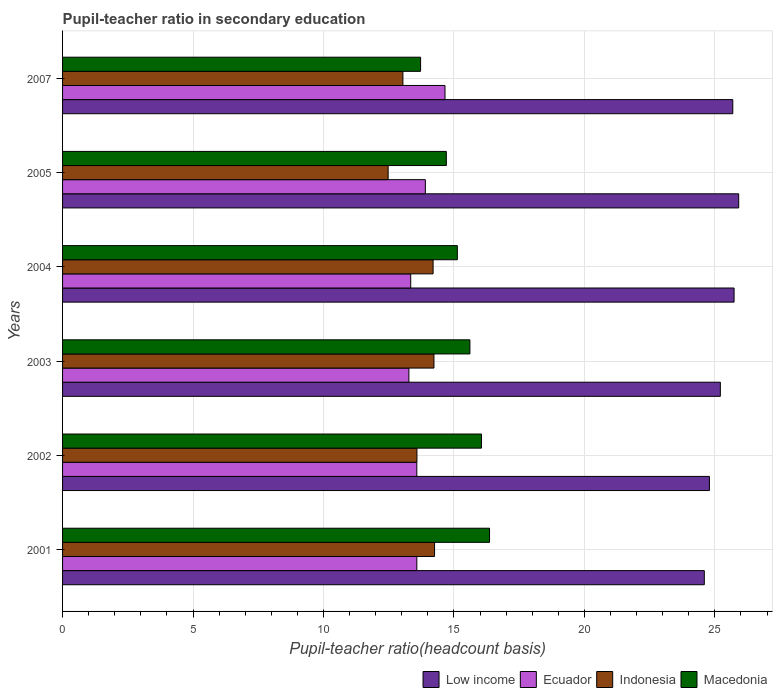How many different coloured bars are there?
Ensure brevity in your answer.  4. Are the number of bars per tick equal to the number of legend labels?
Keep it short and to the point. Yes. Are the number of bars on each tick of the Y-axis equal?
Offer a very short reply. Yes. How many bars are there on the 2nd tick from the bottom?
Offer a very short reply. 4. In how many cases, is the number of bars for a given year not equal to the number of legend labels?
Give a very brief answer. 0. What is the pupil-teacher ratio in secondary education in Low income in 2003?
Provide a succinct answer. 25.21. Across all years, what is the maximum pupil-teacher ratio in secondary education in Ecuador?
Provide a succinct answer. 14.66. Across all years, what is the minimum pupil-teacher ratio in secondary education in Indonesia?
Ensure brevity in your answer.  12.48. What is the total pupil-teacher ratio in secondary education in Macedonia in the graph?
Provide a short and direct response. 91.59. What is the difference between the pupil-teacher ratio in secondary education in Low income in 2001 and that in 2002?
Offer a terse response. -0.2. What is the difference between the pupil-teacher ratio in secondary education in Indonesia in 2003 and the pupil-teacher ratio in secondary education in Low income in 2002?
Your answer should be very brief. -10.56. What is the average pupil-teacher ratio in secondary education in Ecuador per year?
Give a very brief answer. 13.72. In the year 2001, what is the difference between the pupil-teacher ratio in secondary education in Indonesia and pupil-teacher ratio in secondary education in Macedonia?
Your answer should be very brief. -2.11. In how many years, is the pupil-teacher ratio in secondary education in Macedonia greater than 11 ?
Give a very brief answer. 6. What is the ratio of the pupil-teacher ratio in secondary education in Ecuador in 2001 to that in 2003?
Provide a succinct answer. 1.02. Is the pupil-teacher ratio in secondary education in Macedonia in 2003 less than that in 2004?
Ensure brevity in your answer.  No. What is the difference between the highest and the second highest pupil-teacher ratio in secondary education in Low income?
Your answer should be compact. 0.18. What is the difference between the highest and the lowest pupil-teacher ratio in secondary education in Low income?
Your response must be concise. 1.32. In how many years, is the pupil-teacher ratio in secondary education in Macedonia greater than the average pupil-teacher ratio in secondary education in Macedonia taken over all years?
Your answer should be compact. 3. Is the sum of the pupil-teacher ratio in secondary education in Macedonia in 2001 and 2002 greater than the maximum pupil-teacher ratio in secondary education in Low income across all years?
Your answer should be compact. Yes. Is it the case that in every year, the sum of the pupil-teacher ratio in secondary education in Low income and pupil-teacher ratio in secondary education in Indonesia is greater than the sum of pupil-teacher ratio in secondary education in Ecuador and pupil-teacher ratio in secondary education in Macedonia?
Your answer should be compact. Yes. What does the 3rd bar from the top in 2004 represents?
Make the answer very short. Ecuador. How many bars are there?
Offer a terse response. 24. Are all the bars in the graph horizontal?
Your answer should be compact. Yes. How many years are there in the graph?
Give a very brief answer. 6. Are the values on the major ticks of X-axis written in scientific E-notation?
Keep it short and to the point. No. Does the graph contain grids?
Your answer should be compact. Yes. Where does the legend appear in the graph?
Ensure brevity in your answer.  Bottom right. What is the title of the graph?
Keep it short and to the point. Pupil-teacher ratio in secondary education. Does "Malta" appear as one of the legend labels in the graph?
Offer a very short reply. No. What is the label or title of the X-axis?
Provide a short and direct response. Pupil-teacher ratio(headcount basis). What is the label or title of the Y-axis?
Offer a very short reply. Years. What is the Pupil-teacher ratio(headcount basis) in Low income in 2001?
Give a very brief answer. 24.6. What is the Pupil-teacher ratio(headcount basis) of Ecuador in 2001?
Keep it short and to the point. 13.58. What is the Pupil-teacher ratio(headcount basis) in Indonesia in 2001?
Provide a short and direct response. 14.26. What is the Pupil-teacher ratio(headcount basis) of Macedonia in 2001?
Your answer should be compact. 16.36. What is the Pupil-teacher ratio(headcount basis) of Low income in 2002?
Make the answer very short. 24.79. What is the Pupil-teacher ratio(headcount basis) of Ecuador in 2002?
Offer a terse response. 13.58. What is the Pupil-teacher ratio(headcount basis) of Indonesia in 2002?
Your response must be concise. 13.58. What is the Pupil-teacher ratio(headcount basis) in Macedonia in 2002?
Offer a very short reply. 16.06. What is the Pupil-teacher ratio(headcount basis) in Low income in 2003?
Offer a very short reply. 25.21. What is the Pupil-teacher ratio(headcount basis) in Ecuador in 2003?
Offer a terse response. 13.27. What is the Pupil-teacher ratio(headcount basis) of Indonesia in 2003?
Offer a very short reply. 14.23. What is the Pupil-teacher ratio(headcount basis) of Macedonia in 2003?
Offer a very short reply. 15.61. What is the Pupil-teacher ratio(headcount basis) in Low income in 2004?
Provide a short and direct response. 25.74. What is the Pupil-teacher ratio(headcount basis) of Ecuador in 2004?
Provide a short and direct response. 13.34. What is the Pupil-teacher ratio(headcount basis) of Indonesia in 2004?
Offer a very short reply. 14.2. What is the Pupil-teacher ratio(headcount basis) in Macedonia in 2004?
Your answer should be very brief. 15.13. What is the Pupil-teacher ratio(headcount basis) in Low income in 2005?
Offer a terse response. 25.91. What is the Pupil-teacher ratio(headcount basis) of Ecuador in 2005?
Keep it short and to the point. 13.9. What is the Pupil-teacher ratio(headcount basis) in Indonesia in 2005?
Your answer should be compact. 12.48. What is the Pupil-teacher ratio(headcount basis) of Macedonia in 2005?
Provide a succinct answer. 14.71. What is the Pupil-teacher ratio(headcount basis) in Low income in 2007?
Make the answer very short. 25.69. What is the Pupil-teacher ratio(headcount basis) in Ecuador in 2007?
Give a very brief answer. 14.66. What is the Pupil-teacher ratio(headcount basis) of Indonesia in 2007?
Ensure brevity in your answer.  13.04. What is the Pupil-teacher ratio(headcount basis) of Macedonia in 2007?
Offer a very short reply. 13.72. Across all years, what is the maximum Pupil-teacher ratio(headcount basis) of Low income?
Provide a succinct answer. 25.91. Across all years, what is the maximum Pupil-teacher ratio(headcount basis) of Ecuador?
Your response must be concise. 14.66. Across all years, what is the maximum Pupil-teacher ratio(headcount basis) in Indonesia?
Give a very brief answer. 14.26. Across all years, what is the maximum Pupil-teacher ratio(headcount basis) in Macedonia?
Your response must be concise. 16.36. Across all years, what is the minimum Pupil-teacher ratio(headcount basis) of Low income?
Provide a succinct answer. 24.6. Across all years, what is the minimum Pupil-teacher ratio(headcount basis) of Ecuador?
Offer a very short reply. 13.27. Across all years, what is the minimum Pupil-teacher ratio(headcount basis) of Indonesia?
Make the answer very short. 12.48. Across all years, what is the minimum Pupil-teacher ratio(headcount basis) of Macedonia?
Make the answer very short. 13.72. What is the total Pupil-teacher ratio(headcount basis) of Low income in the graph?
Give a very brief answer. 151.94. What is the total Pupil-teacher ratio(headcount basis) in Ecuador in the graph?
Offer a terse response. 82.33. What is the total Pupil-teacher ratio(headcount basis) of Indonesia in the graph?
Your response must be concise. 81.8. What is the total Pupil-teacher ratio(headcount basis) in Macedonia in the graph?
Keep it short and to the point. 91.59. What is the difference between the Pupil-teacher ratio(headcount basis) of Low income in 2001 and that in 2002?
Offer a very short reply. -0.2. What is the difference between the Pupil-teacher ratio(headcount basis) of Ecuador in 2001 and that in 2002?
Your answer should be compact. 0. What is the difference between the Pupil-teacher ratio(headcount basis) in Indonesia in 2001 and that in 2002?
Make the answer very short. 0.68. What is the difference between the Pupil-teacher ratio(headcount basis) in Macedonia in 2001 and that in 2002?
Your answer should be compact. 0.31. What is the difference between the Pupil-teacher ratio(headcount basis) in Low income in 2001 and that in 2003?
Give a very brief answer. -0.61. What is the difference between the Pupil-teacher ratio(headcount basis) in Ecuador in 2001 and that in 2003?
Provide a succinct answer. 0.3. What is the difference between the Pupil-teacher ratio(headcount basis) of Indonesia in 2001 and that in 2003?
Offer a very short reply. 0.02. What is the difference between the Pupil-teacher ratio(headcount basis) in Macedonia in 2001 and that in 2003?
Ensure brevity in your answer.  0.75. What is the difference between the Pupil-teacher ratio(headcount basis) in Low income in 2001 and that in 2004?
Your answer should be compact. -1.14. What is the difference between the Pupil-teacher ratio(headcount basis) in Ecuador in 2001 and that in 2004?
Your answer should be compact. 0.24. What is the difference between the Pupil-teacher ratio(headcount basis) in Indonesia in 2001 and that in 2004?
Provide a short and direct response. 0.06. What is the difference between the Pupil-teacher ratio(headcount basis) of Macedonia in 2001 and that in 2004?
Offer a very short reply. 1.23. What is the difference between the Pupil-teacher ratio(headcount basis) in Low income in 2001 and that in 2005?
Your response must be concise. -1.32. What is the difference between the Pupil-teacher ratio(headcount basis) of Ecuador in 2001 and that in 2005?
Provide a succinct answer. -0.33. What is the difference between the Pupil-teacher ratio(headcount basis) of Indonesia in 2001 and that in 2005?
Your answer should be compact. 1.78. What is the difference between the Pupil-teacher ratio(headcount basis) in Macedonia in 2001 and that in 2005?
Provide a short and direct response. 1.66. What is the difference between the Pupil-teacher ratio(headcount basis) of Low income in 2001 and that in 2007?
Offer a very short reply. -1.09. What is the difference between the Pupil-teacher ratio(headcount basis) of Ecuador in 2001 and that in 2007?
Ensure brevity in your answer.  -1.08. What is the difference between the Pupil-teacher ratio(headcount basis) in Indonesia in 2001 and that in 2007?
Offer a very short reply. 1.21. What is the difference between the Pupil-teacher ratio(headcount basis) of Macedonia in 2001 and that in 2007?
Provide a succinct answer. 2.64. What is the difference between the Pupil-teacher ratio(headcount basis) of Low income in 2002 and that in 2003?
Your answer should be very brief. -0.42. What is the difference between the Pupil-teacher ratio(headcount basis) of Ecuador in 2002 and that in 2003?
Offer a terse response. 0.3. What is the difference between the Pupil-teacher ratio(headcount basis) of Indonesia in 2002 and that in 2003?
Give a very brief answer. -0.65. What is the difference between the Pupil-teacher ratio(headcount basis) in Macedonia in 2002 and that in 2003?
Provide a short and direct response. 0.44. What is the difference between the Pupil-teacher ratio(headcount basis) in Low income in 2002 and that in 2004?
Your answer should be compact. -0.94. What is the difference between the Pupil-teacher ratio(headcount basis) of Ecuador in 2002 and that in 2004?
Keep it short and to the point. 0.23. What is the difference between the Pupil-teacher ratio(headcount basis) of Indonesia in 2002 and that in 2004?
Your answer should be compact. -0.62. What is the difference between the Pupil-teacher ratio(headcount basis) in Macedonia in 2002 and that in 2004?
Give a very brief answer. 0.92. What is the difference between the Pupil-teacher ratio(headcount basis) of Low income in 2002 and that in 2005?
Give a very brief answer. -1.12. What is the difference between the Pupil-teacher ratio(headcount basis) in Ecuador in 2002 and that in 2005?
Give a very brief answer. -0.33. What is the difference between the Pupil-teacher ratio(headcount basis) in Indonesia in 2002 and that in 2005?
Your response must be concise. 1.1. What is the difference between the Pupil-teacher ratio(headcount basis) of Macedonia in 2002 and that in 2005?
Keep it short and to the point. 1.35. What is the difference between the Pupil-teacher ratio(headcount basis) in Low income in 2002 and that in 2007?
Make the answer very short. -0.9. What is the difference between the Pupil-teacher ratio(headcount basis) in Ecuador in 2002 and that in 2007?
Offer a very short reply. -1.08. What is the difference between the Pupil-teacher ratio(headcount basis) of Indonesia in 2002 and that in 2007?
Your answer should be compact. 0.54. What is the difference between the Pupil-teacher ratio(headcount basis) of Macedonia in 2002 and that in 2007?
Ensure brevity in your answer.  2.33. What is the difference between the Pupil-teacher ratio(headcount basis) of Low income in 2003 and that in 2004?
Offer a very short reply. -0.53. What is the difference between the Pupil-teacher ratio(headcount basis) in Ecuador in 2003 and that in 2004?
Give a very brief answer. -0.07. What is the difference between the Pupil-teacher ratio(headcount basis) of Indonesia in 2003 and that in 2004?
Your answer should be very brief. 0.03. What is the difference between the Pupil-teacher ratio(headcount basis) in Macedonia in 2003 and that in 2004?
Provide a short and direct response. 0.48. What is the difference between the Pupil-teacher ratio(headcount basis) of Low income in 2003 and that in 2005?
Provide a short and direct response. -0.7. What is the difference between the Pupil-teacher ratio(headcount basis) in Ecuador in 2003 and that in 2005?
Ensure brevity in your answer.  -0.63. What is the difference between the Pupil-teacher ratio(headcount basis) of Indonesia in 2003 and that in 2005?
Offer a terse response. 1.76. What is the difference between the Pupil-teacher ratio(headcount basis) in Macedonia in 2003 and that in 2005?
Offer a very short reply. 0.9. What is the difference between the Pupil-teacher ratio(headcount basis) of Low income in 2003 and that in 2007?
Keep it short and to the point. -0.48. What is the difference between the Pupil-teacher ratio(headcount basis) of Ecuador in 2003 and that in 2007?
Your answer should be compact. -1.38. What is the difference between the Pupil-teacher ratio(headcount basis) of Indonesia in 2003 and that in 2007?
Your response must be concise. 1.19. What is the difference between the Pupil-teacher ratio(headcount basis) of Macedonia in 2003 and that in 2007?
Give a very brief answer. 1.89. What is the difference between the Pupil-teacher ratio(headcount basis) in Low income in 2004 and that in 2005?
Offer a very short reply. -0.18. What is the difference between the Pupil-teacher ratio(headcount basis) of Ecuador in 2004 and that in 2005?
Make the answer very short. -0.56. What is the difference between the Pupil-teacher ratio(headcount basis) of Indonesia in 2004 and that in 2005?
Ensure brevity in your answer.  1.72. What is the difference between the Pupil-teacher ratio(headcount basis) in Macedonia in 2004 and that in 2005?
Offer a terse response. 0.42. What is the difference between the Pupil-teacher ratio(headcount basis) in Low income in 2004 and that in 2007?
Offer a very short reply. 0.05. What is the difference between the Pupil-teacher ratio(headcount basis) of Ecuador in 2004 and that in 2007?
Offer a terse response. -1.31. What is the difference between the Pupil-teacher ratio(headcount basis) in Indonesia in 2004 and that in 2007?
Keep it short and to the point. 1.16. What is the difference between the Pupil-teacher ratio(headcount basis) of Macedonia in 2004 and that in 2007?
Keep it short and to the point. 1.41. What is the difference between the Pupil-teacher ratio(headcount basis) in Low income in 2005 and that in 2007?
Offer a very short reply. 0.23. What is the difference between the Pupil-teacher ratio(headcount basis) in Ecuador in 2005 and that in 2007?
Your response must be concise. -0.75. What is the difference between the Pupil-teacher ratio(headcount basis) of Indonesia in 2005 and that in 2007?
Provide a succinct answer. -0.57. What is the difference between the Pupil-teacher ratio(headcount basis) in Macedonia in 2005 and that in 2007?
Provide a short and direct response. 0.99. What is the difference between the Pupil-teacher ratio(headcount basis) in Low income in 2001 and the Pupil-teacher ratio(headcount basis) in Ecuador in 2002?
Offer a very short reply. 11.02. What is the difference between the Pupil-teacher ratio(headcount basis) in Low income in 2001 and the Pupil-teacher ratio(headcount basis) in Indonesia in 2002?
Offer a terse response. 11.01. What is the difference between the Pupil-teacher ratio(headcount basis) in Low income in 2001 and the Pupil-teacher ratio(headcount basis) in Macedonia in 2002?
Keep it short and to the point. 8.54. What is the difference between the Pupil-teacher ratio(headcount basis) of Ecuador in 2001 and the Pupil-teacher ratio(headcount basis) of Indonesia in 2002?
Give a very brief answer. -0. What is the difference between the Pupil-teacher ratio(headcount basis) in Ecuador in 2001 and the Pupil-teacher ratio(headcount basis) in Macedonia in 2002?
Make the answer very short. -2.48. What is the difference between the Pupil-teacher ratio(headcount basis) of Indonesia in 2001 and the Pupil-teacher ratio(headcount basis) of Macedonia in 2002?
Offer a very short reply. -1.8. What is the difference between the Pupil-teacher ratio(headcount basis) of Low income in 2001 and the Pupil-teacher ratio(headcount basis) of Ecuador in 2003?
Your answer should be very brief. 11.32. What is the difference between the Pupil-teacher ratio(headcount basis) in Low income in 2001 and the Pupil-teacher ratio(headcount basis) in Indonesia in 2003?
Ensure brevity in your answer.  10.36. What is the difference between the Pupil-teacher ratio(headcount basis) of Low income in 2001 and the Pupil-teacher ratio(headcount basis) of Macedonia in 2003?
Offer a very short reply. 8.98. What is the difference between the Pupil-teacher ratio(headcount basis) in Ecuador in 2001 and the Pupil-teacher ratio(headcount basis) in Indonesia in 2003?
Offer a very short reply. -0.66. What is the difference between the Pupil-teacher ratio(headcount basis) of Ecuador in 2001 and the Pupil-teacher ratio(headcount basis) of Macedonia in 2003?
Your response must be concise. -2.03. What is the difference between the Pupil-teacher ratio(headcount basis) of Indonesia in 2001 and the Pupil-teacher ratio(headcount basis) of Macedonia in 2003?
Keep it short and to the point. -1.36. What is the difference between the Pupil-teacher ratio(headcount basis) of Low income in 2001 and the Pupil-teacher ratio(headcount basis) of Ecuador in 2004?
Your answer should be very brief. 11.25. What is the difference between the Pupil-teacher ratio(headcount basis) of Low income in 2001 and the Pupil-teacher ratio(headcount basis) of Indonesia in 2004?
Your response must be concise. 10.39. What is the difference between the Pupil-teacher ratio(headcount basis) of Low income in 2001 and the Pupil-teacher ratio(headcount basis) of Macedonia in 2004?
Your response must be concise. 9.47. What is the difference between the Pupil-teacher ratio(headcount basis) of Ecuador in 2001 and the Pupil-teacher ratio(headcount basis) of Indonesia in 2004?
Offer a terse response. -0.62. What is the difference between the Pupil-teacher ratio(headcount basis) of Ecuador in 2001 and the Pupil-teacher ratio(headcount basis) of Macedonia in 2004?
Offer a very short reply. -1.55. What is the difference between the Pupil-teacher ratio(headcount basis) of Indonesia in 2001 and the Pupil-teacher ratio(headcount basis) of Macedonia in 2004?
Your answer should be compact. -0.87. What is the difference between the Pupil-teacher ratio(headcount basis) of Low income in 2001 and the Pupil-teacher ratio(headcount basis) of Ecuador in 2005?
Offer a very short reply. 10.69. What is the difference between the Pupil-teacher ratio(headcount basis) in Low income in 2001 and the Pupil-teacher ratio(headcount basis) in Indonesia in 2005?
Keep it short and to the point. 12.12. What is the difference between the Pupil-teacher ratio(headcount basis) of Low income in 2001 and the Pupil-teacher ratio(headcount basis) of Macedonia in 2005?
Provide a succinct answer. 9.89. What is the difference between the Pupil-teacher ratio(headcount basis) of Ecuador in 2001 and the Pupil-teacher ratio(headcount basis) of Indonesia in 2005?
Keep it short and to the point. 1.1. What is the difference between the Pupil-teacher ratio(headcount basis) of Ecuador in 2001 and the Pupil-teacher ratio(headcount basis) of Macedonia in 2005?
Ensure brevity in your answer.  -1.13. What is the difference between the Pupil-teacher ratio(headcount basis) in Indonesia in 2001 and the Pupil-teacher ratio(headcount basis) in Macedonia in 2005?
Provide a short and direct response. -0.45. What is the difference between the Pupil-teacher ratio(headcount basis) of Low income in 2001 and the Pupil-teacher ratio(headcount basis) of Ecuador in 2007?
Your answer should be compact. 9.94. What is the difference between the Pupil-teacher ratio(headcount basis) in Low income in 2001 and the Pupil-teacher ratio(headcount basis) in Indonesia in 2007?
Your response must be concise. 11.55. What is the difference between the Pupil-teacher ratio(headcount basis) in Low income in 2001 and the Pupil-teacher ratio(headcount basis) in Macedonia in 2007?
Your response must be concise. 10.87. What is the difference between the Pupil-teacher ratio(headcount basis) of Ecuador in 2001 and the Pupil-teacher ratio(headcount basis) of Indonesia in 2007?
Provide a short and direct response. 0.53. What is the difference between the Pupil-teacher ratio(headcount basis) of Ecuador in 2001 and the Pupil-teacher ratio(headcount basis) of Macedonia in 2007?
Make the answer very short. -0.14. What is the difference between the Pupil-teacher ratio(headcount basis) of Indonesia in 2001 and the Pupil-teacher ratio(headcount basis) of Macedonia in 2007?
Your response must be concise. 0.54. What is the difference between the Pupil-teacher ratio(headcount basis) in Low income in 2002 and the Pupil-teacher ratio(headcount basis) in Ecuador in 2003?
Your answer should be very brief. 11.52. What is the difference between the Pupil-teacher ratio(headcount basis) of Low income in 2002 and the Pupil-teacher ratio(headcount basis) of Indonesia in 2003?
Provide a short and direct response. 10.56. What is the difference between the Pupil-teacher ratio(headcount basis) in Low income in 2002 and the Pupil-teacher ratio(headcount basis) in Macedonia in 2003?
Give a very brief answer. 9.18. What is the difference between the Pupil-teacher ratio(headcount basis) of Ecuador in 2002 and the Pupil-teacher ratio(headcount basis) of Indonesia in 2003?
Offer a terse response. -0.66. What is the difference between the Pupil-teacher ratio(headcount basis) of Ecuador in 2002 and the Pupil-teacher ratio(headcount basis) of Macedonia in 2003?
Ensure brevity in your answer.  -2.03. What is the difference between the Pupil-teacher ratio(headcount basis) of Indonesia in 2002 and the Pupil-teacher ratio(headcount basis) of Macedonia in 2003?
Provide a succinct answer. -2.03. What is the difference between the Pupil-teacher ratio(headcount basis) in Low income in 2002 and the Pupil-teacher ratio(headcount basis) in Ecuador in 2004?
Offer a terse response. 11.45. What is the difference between the Pupil-teacher ratio(headcount basis) of Low income in 2002 and the Pupil-teacher ratio(headcount basis) of Indonesia in 2004?
Keep it short and to the point. 10.59. What is the difference between the Pupil-teacher ratio(headcount basis) in Low income in 2002 and the Pupil-teacher ratio(headcount basis) in Macedonia in 2004?
Give a very brief answer. 9.66. What is the difference between the Pupil-teacher ratio(headcount basis) of Ecuador in 2002 and the Pupil-teacher ratio(headcount basis) of Indonesia in 2004?
Provide a short and direct response. -0.62. What is the difference between the Pupil-teacher ratio(headcount basis) of Ecuador in 2002 and the Pupil-teacher ratio(headcount basis) of Macedonia in 2004?
Ensure brevity in your answer.  -1.55. What is the difference between the Pupil-teacher ratio(headcount basis) in Indonesia in 2002 and the Pupil-teacher ratio(headcount basis) in Macedonia in 2004?
Offer a very short reply. -1.55. What is the difference between the Pupil-teacher ratio(headcount basis) of Low income in 2002 and the Pupil-teacher ratio(headcount basis) of Ecuador in 2005?
Offer a very short reply. 10.89. What is the difference between the Pupil-teacher ratio(headcount basis) in Low income in 2002 and the Pupil-teacher ratio(headcount basis) in Indonesia in 2005?
Provide a short and direct response. 12.31. What is the difference between the Pupil-teacher ratio(headcount basis) in Low income in 2002 and the Pupil-teacher ratio(headcount basis) in Macedonia in 2005?
Provide a succinct answer. 10.08. What is the difference between the Pupil-teacher ratio(headcount basis) of Ecuador in 2002 and the Pupil-teacher ratio(headcount basis) of Indonesia in 2005?
Your response must be concise. 1.1. What is the difference between the Pupil-teacher ratio(headcount basis) of Ecuador in 2002 and the Pupil-teacher ratio(headcount basis) of Macedonia in 2005?
Your answer should be compact. -1.13. What is the difference between the Pupil-teacher ratio(headcount basis) of Indonesia in 2002 and the Pupil-teacher ratio(headcount basis) of Macedonia in 2005?
Ensure brevity in your answer.  -1.13. What is the difference between the Pupil-teacher ratio(headcount basis) of Low income in 2002 and the Pupil-teacher ratio(headcount basis) of Ecuador in 2007?
Offer a very short reply. 10.13. What is the difference between the Pupil-teacher ratio(headcount basis) of Low income in 2002 and the Pupil-teacher ratio(headcount basis) of Indonesia in 2007?
Keep it short and to the point. 11.75. What is the difference between the Pupil-teacher ratio(headcount basis) of Low income in 2002 and the Pupil-teacher ratio(headcount basis) of Macedonia in 2007?
Give a very brief answer. 11.07. What is the difference between the Pupil-teacher ratio(headcount basis) in Ecuador in 2002 and the Pupil-teacher ratio(headcount basis) in Indonesia in 2007?
Keep it short and to the point. 0.53. What is the difference between the Pupil-teacher ratio(headcount basis) of Ecuador in 2002 and the Pupil-teacher ratio(headcount basis) of Macedonia in 2007?
Your response must be concise. -0.14. What is the difference between the Pupil-teacher ratio(headcount basis) of Indonesia in 2002 and the Pupil-teacher ratio(headcount basis) of Macedonia in 2007?
Give a very brief answer. -0.14. What is the difference between the Pupil-teacher ratio(headcount basis) of Low income in 2003 and the Pupil-teacher ratio(headcount basis) of Ecuador in 2004?
Make the answer very short. 11.87. What is the difference between the Pupil-teacher ratio(headcount basis) in Low income in 2003 and the Pupil-teacher ratio(headcount basis) in Indonesia in 2004?
Provide a short and direct response. 11.01. What is the difference between the Pupil-teacher ratio(headcount basis) of Low income in 2003 and the Pupil-teacher ratio(headcount basis) of Macedonia in 2004?
Offer a very short reply. 10.08. What is the difference between the Pupil-teacher ratio(headcount basis) in Ecuador in 2003 and the Pupil-teacher ratio(headcount basis) in Indonesia in 2004?
Provide a short and direct response. -0.93. What is the difference between the Pupil-teacher ratio(headcount basis) of Ecuador in 2003 and the Pupil-teacher ratio(headcount basis) of Macedonia in 2004?
Provide a short and direct response. -1.86. What is the difference between the Pupil-teacher ratio(headcount basis) in Indonesia in 2003 and the Pupil-teacher ratio(headcount basis) in Macedonia in 2004?
Give a very brief answer. -0.9. What is the difference between the Pupil-teacher ratio(headcount basis) of Low income in 2003 and the Pupil-teacher ratio(headcount basis) of Ecuador in 2005?
Your answer should be compact. 11.31. What is the difference between the Pupil-teacher ratio(headcount basis) of Low income in 2003 and the Pupil-teacher ratio(headcount basis) of Indonesia in 2005?
Provide a short and direct response. 12.73. What is the difference between the Pupil-teacher ratio(headcount basis) in Low income in 2003 and the Pupil-teacher ratio(headcount basis) in Macedonia in 2005?
Your response must be concise. 10.5. What is the difference between the Pupil-teacher ratio(headcount basis) of Ecuador in 2003 and the Pupil-teacher ratio(headcount basis) of Indonesia in 2005?
Ensure brevity in your answer.  0.8. What is the difference between the Pupil-teacher ratio(headcount basis) of Ecuador in 2003 and the Pupil-teacher ratio(headcount basis) of Macedonia in 2005?
Your answer should be compact. -1.43. What is the difference between the Pupil-teacher ratio(headcount basis) in Indonesia in 2003 and the Pupil-teacher ratio(headcount basis) in Macedonia in 2005?
Your answer should be compact. -0.47. What is the difference between the Pupil-teacher ratio(headcount basis) of Low income in 2003 and the Pupil-teacher ratio(headcount basis) of Ecuador in 2007?
Your response must be concise. 10.55. What is the difference between the Pupil-teacher ratio(headcount basis) of Low income in 2003 and the Pupil-teacher ratio(headcount basis) of Indonesia in 2007?
Your answer should be compact. 12.17. What is the difference between the Pupil-teacher ratio(headcount basis) of Low income in 2003 and the Pupil-teacher ratio(headcount basis) of Macedonia in 2007?
Provide a short and direct response. 11.49. What is the difference between the Pupil-teacher ratio(headcount basis) of Ecuador in 2003 and the Pupil-teacher ratio(headcount basis) of Indonesia in 2007?
Your response must be concise. 0.23. What is the difference between the Pupil-teacher ratio(headcount basis) of Ecuador in 2003 and the Pupil-teacher ratio(headcount basis) of Macedonia in 2007?
Provide a succinct answer. -0.45. What is the difference between the Pupil-teacher ratio(headcount basis) in Indonesia in 2003 and the Pupil-teacher ratio(headcount basis) in Macedonia in 2007?
Ensure brevity in your answer.  0.51. What is the difference between the Pupil-teacher ratio(headcount basis) in Low income in 2004 and the Pupil-teacher ratio(headcount basis) in Ecuador in 2005?
Offer a terse response. 11.83. What is the difference between the Pupil-teacher ratio(headcount basis) in Low income in 2004 and the Pupil-teacher ratio(headcount basis) in Indonesia in 2005?
Your answer should be very brief. 13.26. What is the difference between the Pupil-teacher ratio(headcount basis) in Low income in 2004 and the Pupil-teacher ratio(headcount basis) in Macedonia in 2005?
Make the answer very short. 11.03. What is the difference between the Pupil-teacher ratio(headcount basis) of Ecuador in 2004 and the Pupil-teacher ratio(headcount basis) of Indonesia in 2005?
Your answer should be compact. 0.86. What is the difference between the Pupil-teacher ratio(headcount basis) of Ecuador in 2004 and the Pupil-teacher ratio(headcount basis) of Macedonia in 2005?
Your answer should be very brief. -1.37. What is the difference between the Pupil-teacher ratio(headcount basis) of Indonesia in 2004 and the Pupil-teacher ratio(headcount basis) of Macedonia in 2005?
Offer a terse response. -0.51. What is the difference between the Pupil-teacher ratio(headcount basis) of Low income in 2004 and the Pupil-teacher ratio(headcount basis) of Ecuador in 2007?
Provide a short and direct response. 11.08. What is the difference between the Pupil-teacher ratio(headcount basis) in Low income in 2004 and the Pupil-teacher ratio(headcount basis) in Indonesia in 2007?
Offer a very short reply. 12.69. What is the difference between the Pupil-teacher ratio(headcount basis) of Low income in 2004 and the Pupil-teacher ratio(headcount basis) of Macedonia in 2007?
Keep it short and to the point. 12.01. What is the difference between the Pupil-teacher ratio(headcount basis) in Ecuador in 2004 and the Pupil-teacher ratio(headcount basis) in Indonesia in 2007?
Provide a short and direct response. 0.3. What is the difference between the Pupil-teacher ratio(headcount basis) in Ecuador in 2004 and the Pupil-teacher ratio(headcount basis) in Macedonia in 2007?
Give a very brief answer. -0.38. What is the difference between the Pupil-teacher ratio(headcount basis) of Indonesia in 2004 and the Pupil-teacher ratio(headcount basis) of Macedonia in 2007?
Ensure brevity in your answer.  0.48. What is the difference between the Pupil-teacher ratio(headcount basis) of Low income in 2005 and the Pupil-teacher ratio(headcount basis) of Ecuador in 2007?
Provide a succinct answer. 11.26. What is the difference between the Pupil-teacher ratio(headcount basis) of Low income in 2005 and the Pupil-teacher ratio(headcount basis) of Indonesia in 2007?
Ensure brevity in your answer.  12.87. What is the difference between the Pupil-teacher ratio(headcount basis) of Low income in 2005 and the Pupil-teacher ratio(headcount basis) of Macedonia in 2007?
Offer a very short reply. 12.19. What is the difference between the Pupil-teacher ratio(headcount basis) in Ecuador in 2005 and the Pupil-teacher ratio(headcount basis) in Indonesia in 2007?
Offer a terse response. 0.86. What is the difference between the Pupil-teacher ratio(headcount basis) in Ecuador in 2005 and the Pupil-teacher ratio(headcount basis) in Macedonia in 2007?
Provide a succinct answer. 0.18. What is the difference between the Pupil-teacher ratio(headcount basis) of Indonesia in 2005 and the Pupil-teacher ratio(headcount basis) of Macedonia in 2007?
Provide a short and direct response. -1.24. What is the average Pupil-teacher ratio(headcount basis) of Low income per year?
Offer a very short reply. 25.32. What is the average Pupil-teacher ratio(headcount basis) in Ecuador per year?
Offer a very short reply. 13.72. What is the average Pupil-teacher ratio(headcount basis) of Indonesia per year?
Offer a very short reply. 13.63. What is the average Pupil-teacher ratio(headcount basis) in Macedonia per year?
Keep it short and to the point. 15.27. In the year 2001, what is the difference between the Pupil-teacher ratio(headcount basis) in Low income and Pupil-teacher ratio(headcount basis) in Ecuador?
Your answer should be very brief. 11.02. In the year 2001, what is the difference between the Pupil-teacher ratio(headcount basis) in Low income and Pupil-teacher ratio(headcount basis) in Indonesia?
Make the answer very short. 10.34. In the year 2001, what is the difference between the Pupil-teacher ratio(headcount basis) in Low income and Pupil-teacher ratio(headcount basis) in Macedonia?
Make the answer very short. 8.23. In the year 2001, what is the difference between the Pupil-teacher ratio(headcount basis) of Ecuador and Pupil-teacher ratio(headcount basis) of Indonesia?
Provide a short and direct response. -0.68. In the year 2001, what is the difference between the Pupil-teacher ratio(headcount basis) in Ecuador and Pupil-teacher ratio(headcount basis) in Macedonia?
Ensure brevity in your answer.  -2.79. In the year 2001, what is the difference between the Pupil-teacher ratio(headcount basis) of Indonesia and Pupil-teacher ratio(headcount basis) of Macedonia?
Give a very brief answer. -2.11. In the year 2002, what is the difference between the Pupil-teacher ratio(headcount basis) in Low income and Pupil-teacher ratio(headcount basis) in Ecuador?
Your answer should be compact. 11.21. In the year 2002, what is the difference between the Pupil-teacher ratio(headcount basis) of Low income and Pupil-teacher ratio(headcount basis) of Indonesia?
Your answer should be compact. 11.21. In the year 2002, what is the difference between the Pupil-teacher ratio(headcount basis) in Low income and Pupil-teacher ratio(headcount basis) in Macedonia?
Provide a succinct answer. 8.74. In the year 2002, what is the difference between the Pupil-teacher ratio(headcount basis) of Ecuador and Pupil-teacher ratio(headcount basis) of Indonesia?
Provide a succinct answer. -0. In the year 2002, what is the difference between the Pupil-teacher ratio(headcount basis) in Ecuador and Pupil-teacher ratio(headcount basis) in Macedonia?
Keep it short and to the point. -2.48. In the year 2002, what is the difference between the Pupil-teacher ratio(headcount basis) of Indonesia and Pupil-teacher ratio(headcount basis) of Macedonia?
Provide a succinct answer. -2.47. In the year 2003, what is the difference between the Pupil-teacher ratio(headcount basis) in Low income and Pupil-teacher ratio(headcount basis) in Ecuador?
Offer a terse response. 11.94. In the year 2003, what is the difference between the Pupil-teacher ratio(headcount basis) in Low income and Pupil-teacher ratio(headcount basis) in Indonesia?
Your answer should be very brief. 10.98. In the year 2003, what is the difference between the Pupil-teacher ratio(headcount basis) in Low income and Pupil-teacher ratio(headcount basis) in Macedonia?
Provide a short and direct response. 9.6. In the year 2003, what is the difference between the Pupil-teacher ratio(headcount basis) in Ecuador and Pupil-teacher ratio(headcount basis) in Indonesia?
Keep it short and to the point. -0.96. In the year 2003, what is the difference between the Pupil-teacher ratio(headcount basis) of Ecuador and Pupil-teacher ratio(headcount basis) of Macedonia?
Offer a terse response. -2.34. In the year 2003, what is the difference between the Pupil-teacher ratio(headcount basis) in Indonesia and Pupil-teacher ratio(headcount basis) in Macedonia?
Make the answer very short. -1.38. In the year 2004, what is the difference between the Pupil-teacher ratio(headcount basis) of Low income and Pupil-teacher ratio(headcount basis) of Ecuador?
Provide a succinct answer. 12.39. In the year 2004, what is the difference between the Pupil-teacher ratio(headcount basis) in Low income and Pupil-teacher ratio(headcount basis) in Indonesia?
Your answer should be very brief. 11.54. In the year 2004, what is the difference between the Pupil-teacher ratio(headcount basis) in Low income and Pupil-teacher ratio(headcount basis) in Macedonia?
Your answer should be very brief. 10.61. In the year 2004, what is the difference between the Pupil-teacher ratio(headcount basis) in Ecuador and Pupil-teacher ratio(headcount basis) in Indonesia?
Provide a succinct answer. -0.86. In the year 2004, what is the difference between the Pupil-teacher ratio(headcount basis) of Ecuador and Pupil-teacher ratio(headcount basis) of Macedonia?
Keep it short and to the point. -1.79. In the year 2004, what is the difference between the Pupil-teacher ratio(headcount basis) in Indonesia and Pupil-teacher ratio(headcount basis) in Macedonia?
Your response must be concise. -0.93. In the year 2005, what is the difference between the Pupil-teacher ratio(headcount basis) of Low income and Pupil-teacher ratio(headcount basis) of Ecuador?
Make the answer very short. 12.01. In the year 2005, what is the difference between the Pupil-teacher ratio(headcount basis) in Low income and Pupil-teacher ratio(headcount basis) in Indonesia?
Offer a very short reply. 13.44. In the year 2005, what is the difference between the Pupil-teacher ratio(headcount basis) of Low income and Pupil-teacher ratio(headcount basis) of Macedonia?
Provide a short and direct response. 11.21. In the year 2005, what is the difference between the Pupil-teacher ratio(headcount basis) of Ecuador and Pupil-teacher ratio(headcount basis) of Indonesia?
Offer a terse response. 1.43. In the year 2005, what is the difference between the Pupil-teacher ratio(headcount basis) of Ecuador and Pupil-teacher ratio(headcount basis) of Macedonia?
Offer a very short reply. -0.8. In the year 2005, what is the difference between the Pupil-teacher ratio(headcount basis) of Indonesia and Pupil-teacher ratio(headcount basis) of Macedonia?
Ensure brevity in your answer.  -2.23. In the year 2007, what is the difference between the Pupil-teacher ratio(headcount basis) in Low income and Pupil-teacher ratio(headcount basis) in Ecuador?
Offer a terse response. 11.03. In the year 2007, what is the difference between the Pupil-teacher ratio(headcount basis) in Low income and Pupil-teacher ratio(headcount basis) in Indonesia?
Give a very brief answer. 12.64. In the year 2007, what is the difference between the Pupil-teacher ratio(headcount basis) in Low income and Pupil-teacher ratio(headcount basis) in Macedonia?
Make the answer very short. 11.97. In the year 2007, what is the difference between the Pupil-teacher ratio(headcount basis) in Ecuador and Pupil-teacher ratio(headcount basis) in Indonesia?
Ensure brevity in your answer.  1.61. In the year 2007, what is the difference between the Pupil-teacher ratio(headcount basis) of Ecuador and Pupil-teacher ratio(headcount basis) of Macedonia?
Offer a terse response. 0.94. In the year 2007, what is the difference between the Pupil-teacher ratio(headcount basis) of Indonesia and Pupil-teacher ratio(headcount basis) of Macedonia?
Your answer should be very brief. -0.68. What is the ratio of the Pupil-teacher ratio(headcount basis) of Low income in 2001 to that in 2002?
Provide a short and direct response. 0.99. What is the ratio of the Pupil-teacher ratio(headcount basis) of Indonesia in 2001 to that in 2002?
Make the answer very short. 1.05. What is the ratio of the Pupil-teacher ratio(headcount basis) in Macedonia in 2001 to that in 2002?
Offer a very short reply. 1.02. What is the ratio of the Pupil-teacher ratio(headcount basis) of Low income in 2001 to that in 2003?
Your response must be concise. 0.98. What is the ratio of the Pupil-teacher ratio(headcount basis) in Ecuador in 2001 to that in 2003?
Keep it short and to the point. 1.02. What is the ratio of the Pupil-teacher ratio(headcount basis) of Macedonia in 2001 to that in 2003?
Keep it short and to the point. 1.05. What is the ratio of the Pupil-teacher ratio(headcount basis) of Low income in 2001 to that in 2004?
Provide a succinct answer. 0.96. What is the ratio of the Pupil-teacher ratio(headcount basis) of Ecuador in 2001 to that in 2004?
Your answer should be very brief. 1.02. What is the ratio of the Pupil-teacher ratio(headcount basis) in Indonesia in 2001 to that in 2004?
Your response must be concise. 1. What is the ratio of the Pupil-teacher ratio(headcount basis) in Macedonia in 2001 to that in 2004?
Offer a very short reply. 1.08. What is the ratio of the Pupil-teacher ratio(headcount basis) of Low income in 2001 to that in 2005?
Provide a short and direct response. 0.95. What is the ratio of the Pupil-teacher ratio(headcount basis) of Ecuador in 2001 to that in 2005?
Offer a terse response. 0.98. What is the ratio of the Pupil-teacher ratio(headcount basis) in Indonesia in 2001 to that in 2005?
Provide a succinct answer. 1.14. What is the ratio of the Pupil-teacher ratio(headcount basis) in Macedonia in 2001 to that in 2005?
Your response must be concise. 1.11. What is the ratio of the Pupil-teacher ratio(headcount basis) of Low income in 2001 to that in 2007?
Keep it short and to the point. 0.96. What is the ratio of the Pupil-teacher ratio(headcount basis) of Ecuador in 2001 to that in 2007?
Offer a terse response. 0.93. What is the ratio of the Pupil-teacher ratio(headcount basis) of Indonesia in 2001 to that in 2007?
Offer a terse response. 1.09. What is the ratio of the Pupil-teacher ratio(headcount basis) of Macedonia in 2001 to that in 2007?
Provide a short and direct response. 1.19. What is the ratio of the Pupil-teacher ratio(headcount basis) in Low income in 2002 to that in 2003?
Your answer should be very brief. 0.98. What is the ratio of the Pupil-teacher ratio(headcount basis) of Ecuador in 2002 to that in 2003?
Keep it short and to the point. 1.02. What is the ratio of the Pupil-teacher ratio(headcount basis) of Indonesia in 2002 to that in 2003?
Ensure brevity in your answer.  0.95. What is the ratio of the Pupil-teacher ratio(headcount basis) of Macedonia in 2002 to that in 2003?
Offer a very short reply. 1.03. What is the ratio of the Pupil-teacher ratio(headcount basis) of Low income in 2002 to that in 2004?
Offer a very short reply. 0.96. What is the ratio of the Pupil-teacher ratio(headcount basis) in Ecuador in 2002 to that in 2004?
Keep it short and to the point. 1.02. What is the ratio of the Pupil-teacher ratio(headcount basis) in Indonesia in 2002 to that in 2004?
Give a very brief answer. 0.96. What is the ratio of the Pupil-teacher ratio(headcount basis) in Macedonia in 2002 to that in 2004?
Your response must be concise. 1.06. What is the ratio of the Pupil-teacher ratio(headcount basis) of Low income in 2002 to that in 2005?
Provide a short and direct response. 0.96. What is the ratio of the Pupil-teacher ratio(headcount basis) of Ecuador in 2002 to that in 2005?
Your answer should be very brief. 0.98. What is the ratio of the Pupil-teacher ratio(headcount basis) of Indonesia in 2002 to that in 2005?
Your response must be concise. 1.09. What is the ratio of the Pupil-teacher ratio(headcount basis) of Macedonia in 2002 to that in 2005?
Keep it short and to the point. 1.09. What is the ratio of the Pupil-teacher ratio(headcount basis) in Low income in 2002 to that in 2007?
Provide a succinct answer. 0.97. What is the ratio of the Pupil-teacher ratio(headcount basis) in Ecuador in 2002 to that in 2007?
Offer a terse response. 0.93. What is the ratio of the Pupil-teacher ratio(headcount basis) in Indonesia in 2002 to that in 2007?
Offer a very short reply. 1.04. What is the ratio of the Pupil-teacher ratio(headcount basis) of Macedonia in 2002 to that in 2007?
Keep it short and to the point. 1.17. What is the ratio of the Pupil-teacher ratio(headcount basis) in Low income in 2003 to that in 2004?
Ensure brevity in your answer.  0.98. What is the ratio of the Pupil-teacher ratio(headcount basis) in Ecuador in 2003 to that in 2004?
Make the answer very short. 0.99. What is the ratio of the Pupil-teacher ratio(headcount basis) of Macedonia in 2003 to that in 2004?
Your answer should be very brief. 1.03. What is the ratio of the Pupil-teacher ratio(headcount basis) in Low income in 2003 to that in 2005?
Provide a short and direct response. 0.97. What is the ratio of the Pupil-teacher ratio(headcount basis) in Ecuador in 2003 to that in 2005?
Give a very brief answer. 0.95. What is the ratio of the Pupil-teacher ratio(headcount basis) in Indonesia in 2003 to that in 2005?
Your answer should be compact. 1.14. What is the ratio of the Pupil-teacher ratio(headcount basis) in Macedonia in 2003 to that in 2005?
Keep it short and to the point. 1.06. What is the ratio of the Pupil-teacher ratio(headcount basis) in Low income in 2003 to that in 2007?
Provide a short and direct response. 0.98. What is the ratio of the Pupil-teacher ratio(headcount basis) of Ecuador in 2003 to that in 2007?
Your response must be concise. 0.91. What is the ratio of the Pupil-teacher ratio(headcount basis) of Indonesia in 2003 to that in 2007?
Keep it short and to the point. 1.09. What is the ratio of the Pupil-teacher ratio(headcount basis) of Macedonia in 2003 to that in 2007?
Give a very brief answer. 1.14. What is the ratio of the Pupil-teacher ratio(headcount basis) in Low income in 2004 to that in 2005?
Ensure brevity in your answer.  0.99. What is the ratio of the Pupil-teacher ratio(headcount basis) of Ecuador in 2004 to that in 2005?
Keep it short and to the point. 0.96. What is the ratio of the Pupil-teacher ratio(headcount basis) in Indonesia in 2004 to that in 2005?
Your answer should be very brief. 1.14. What is the ratio of the Pupil-teacher ratio(headcount basis) of Macedonia in 2004 to that in 2005?
Provide a succinct answer. 1.03. What is the ratio of the Pupil-teacher ratio(headcount basis) of Ecuador in 2004 to that in 2007?
Ensure brevity in your answer.  0.91. What is the ratio of the Pupil-teacher ratio(headcount basis) in Indonesia in 2004 to that in 2007?
Provide a short and direct response. 1.09. What is the ratio of the Pupil-teacher ratio(headcount basis) in Macedonia in 2004 to that in 2007?
Give a very brief answer. 1.1. What is the ratio of the Pupil-teacher ratio(headcount basis) of Low income in 2005 to that in 2007?
Provide a short and direct response. 1.01. What is the ratio of the Pupil-teacher ratio(headcount basis) in Ecuador in 2005 to that in 2007?
Ensure brevity in your answer.  0.95. What is the ratio of the Pupil-teacher ratio(headcount basis) of Indonesia in 2005 to that in 2007?
Your response must be concise. 0.96. What is the ratio of the Pupil-teacher ratio(headcount basis) in Macedonia in 2005 to that in 2007?
Offer a terse response. 1.07. What is the difference between the highest and the second highest Pupil-teacher ratio(headcount basis) of Low income?
Offer a very short reply. 0.18. What is the difference between the highest and the second highest Pupil-teacher ratio(headcount basis) in Ecuador?
Offer a very short reply. 0.75. What is the difference between the highest and the second highest Pupil-teacher ratio(headcount basis) in Indonesia?
Ensure brevity in your answer.  0.02. What is the difference between the highest and the second highest Pupil-teacher ratio(headcount basis) in Macedonia?
Keep it short and to the point. 0.31. What is the difference between the highest and the lowest Pupil-teacher ratio(headcount basis) of Low income?
Provide a succinct answer. 1.32. What is the difference between the highest and the lowest Pupil-teacher ratio(headcount basis) of Ecuador?
Offer a very short reply. 1.38. What is the difference between the highest and the lowest Pupil-teacher ratio(headcount basis) of Indonesia?
Your answer should be compact. 1.78. What is the difference between the highest and the lowest Pupil-teacher ratio(headcount basis) in Macedonia?
Offer a terse response. 2.64. 